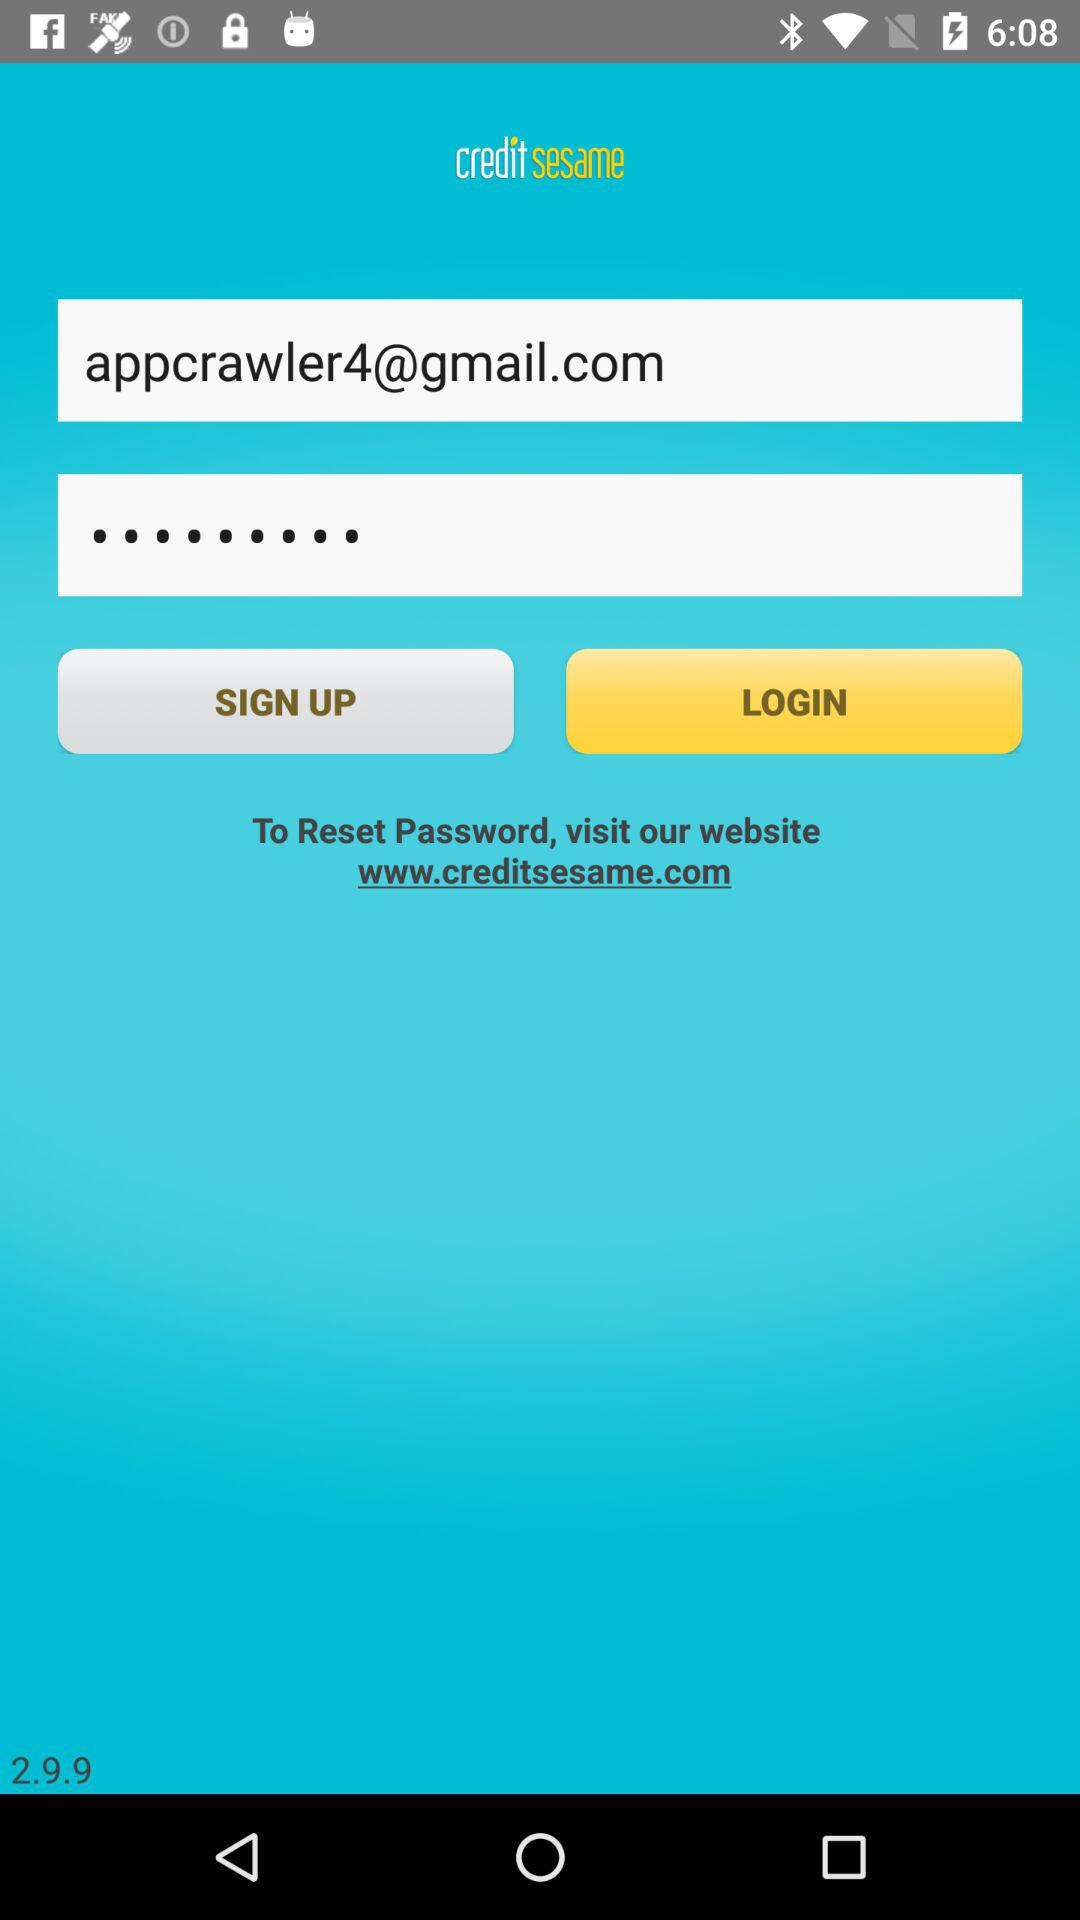What is the email address given? The email address is appcrawler4@gmail.com. 